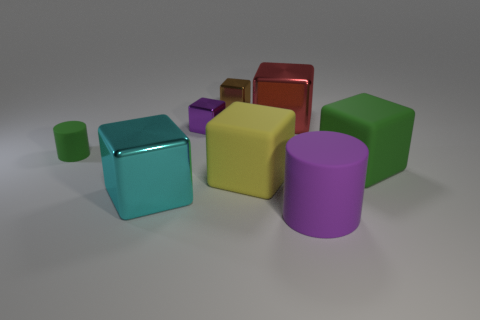Subtract 5 cubes. How many cubes are left? 1 Add 2 big red matte blocks. How many objects exist? 10 Subtract all brown cubes. How many cubes are left? 5 Subtract all cubes. How many objects are left? 2 Subtract all red blocks. How many blocks are left? 5 Subtract 1 purple blocks. How many objects are left? 7 Subtract all blue cylinders. Subtract all gray cubes. How many cylinders are left? 2 Subtract all purple cylinders. How many gray blocks are left? 0 Subtract all gray matte objects. Subtract all big objects. How many objects are left? 3 Add 8 small cylinders. How many small cylinders are left? 9 